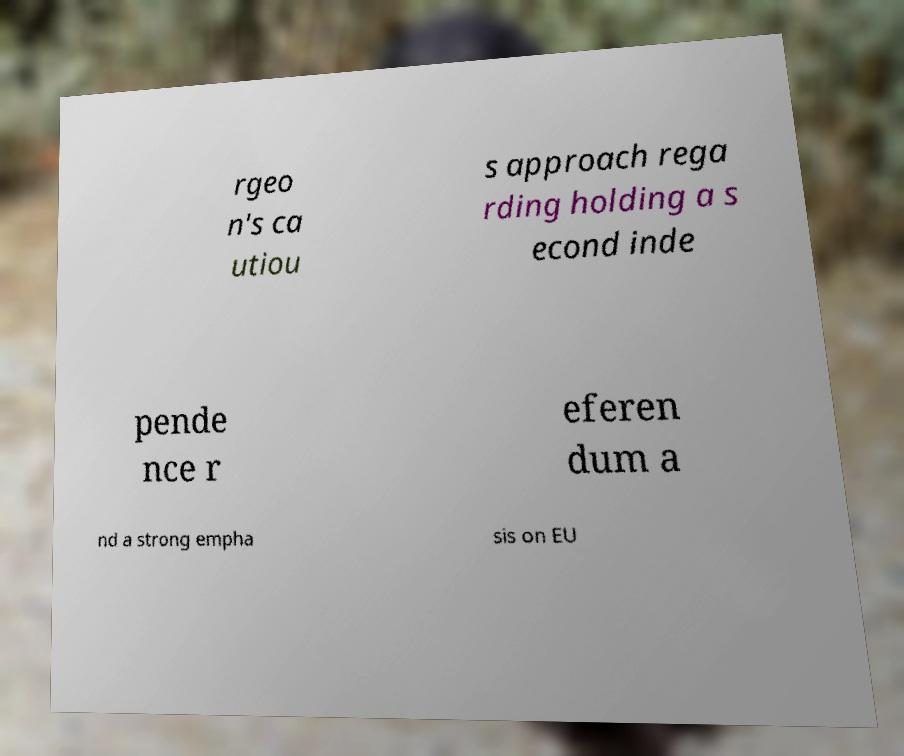Can you read and provide the text displayed in the image?This photo seems to have some interesting text. Can you extract and type it out for me? rgeo n's ca utiou s approach rega rding holding a s econd inde pende nce r eferen dum a nd a strong empha sis on EU 